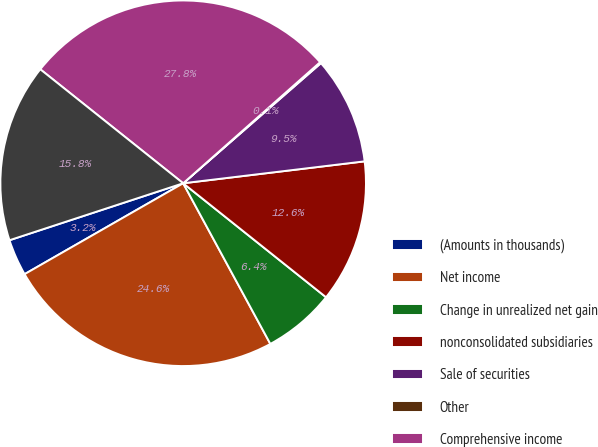Convert chart to OTSL. <chart><loc_0><loc_0><loc_500><loc_500><pie_chart><fcel>(Amounts in thousands)<fcel>Net income<fcel>Change in unrealized net gain<fcel>nonconsolidated subsidiaries<fcel>Sale of securities<fcel>Other<fcel>Comprehensive income<fcel>Comprehensive (income)<nl><fcel>3.24%<fcel>24.63%<fcel>6.37%<fcel>12.63%<fcel>9.5%<fcel>0.11%<fcel>27.76%<fcel>15.76%<nl></chart> 